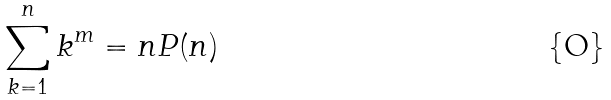Convert formula to latex. <formula><loc_0><loc_0><loc_500><loc_500>\sum _ { k = 1 } ^ { n } k ^ { m } = n P ( n )</formula> 